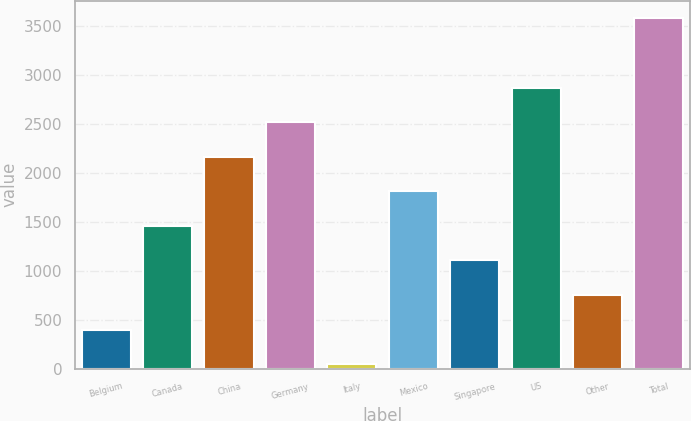Convert chart. <chart><loc_0><loc_0><loc_500><loc_500><bar_chart><fcel>Belgium<fcel>Canada<fcel>China<fcel>Germany<fcel>Italy<fcel>Mexico<fcel>Singapore<fcel>US<fcel>Other<fcel>Total<nl><fcel>398.2<fcel>1457.8<fcel>2164.2<fcel>2517.4<fcel>45<fcel>1811<fcel>1104.6<fcel>2870.6<fcel>751.4<fcel>3577<nl></chart> 